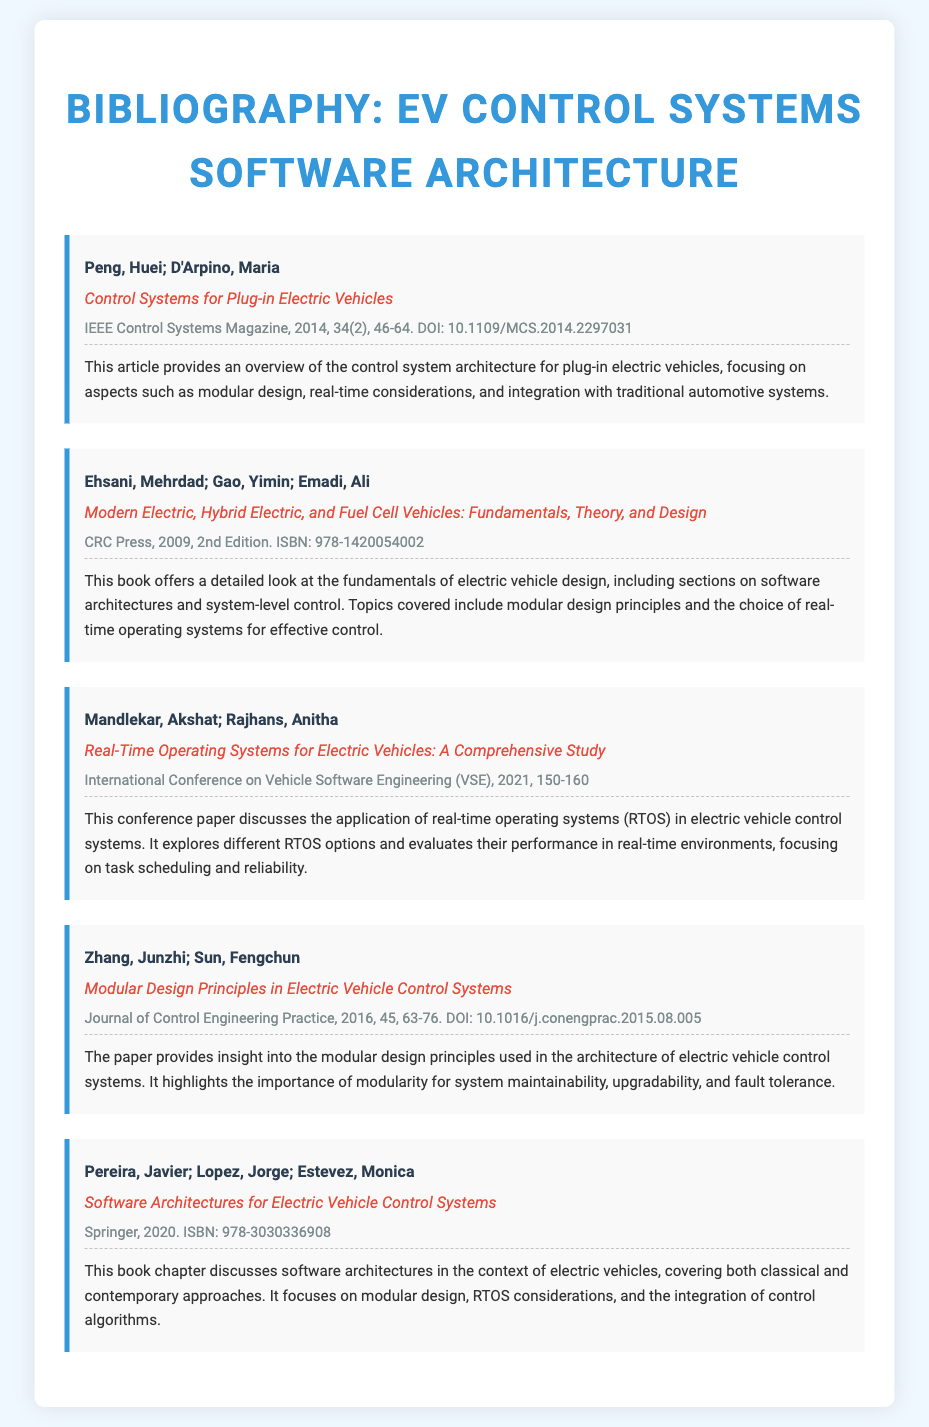what is the title of the first entry? The title of the first entry is provided in the document.
Answer: Control Systems for Plug-in Electric Vehicles who are the authors of the second entry? The authors of the second entry are listed as part of the citation.
Answer: Ehsani, Mehrdad; Gao, Yimin; Emadi, Ali which journal published the fourth entry? The publication details of the fourth entry indicate the journal.
Answer: Journal of Control Engineering Practice what is the publication year of the entry authored by Mandlekar and Rajhans? The publication year is specifically stated in the entry information.
Answer: 2021 how many entries focus on modular design principles? This requires the reader to identify entries mentioning modular design from the abstracts.
Answer: 3 what is the DOI of the first entry? The DOI is mentioned in the details of the first entry.
Answer: 10.1109/MCS.2014.2297031 which book offers a comprehensive discussion on real-time operating systems in electric vehicles? By examining the abstracts, the relevant book can be identified.
Answer: Real-Time Operating Systems for Electric Vehicles: A Comprehensive Study in which year was the book Modern Electric, Hybrid Electric, and Fuel Cell Vehicles published? The publication year is specified in the citation details.
Answer: 2009 